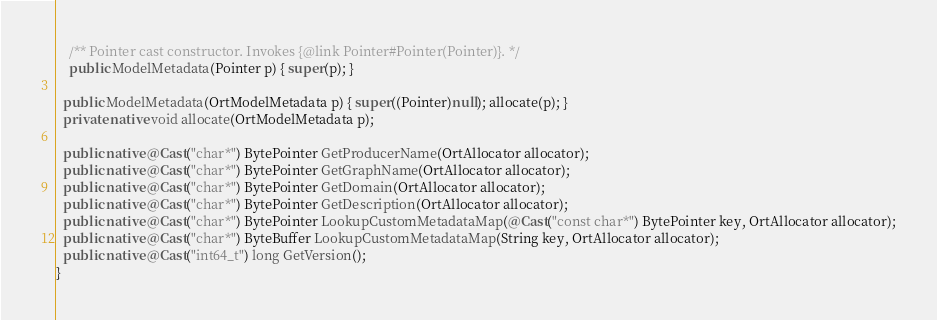<code> <loc_0><loc_0><loc_500><loc_500><_Java_>    /** Pointer cast constructor. Invokes {@link Pointer#Pointer(Pointer)}. */
    public ModelMetadata(Pointer p) { super(p); }

  public ModelMetadata(OrtModelMetadata p) { super((Pointer)null); allocate(p); }
  private native void allocate(OrtModelMetadata p);

  public native @Cast("char*") BytePointer GetProducerName(OrtAllocator allocator);
  public native @Cast("char*") BytePointer GetGraphName(OrtAllocator allocator);
  public native @Cast("char*") BytePointer GetDomain(OrtAllocator allocator);
  public native @Cast("char*") BytePointer GetDescription(OrtAllocator allocator);
  public native @Cast("char*") BytePointer LookupCustomMetadataMap(@Cast("const char*") BytePointer key, OrtAllocator allocator);
  public native @Cast("char*") ByteBuffer LookupCustomMetadataMap(String key, OrtAllocator allocator);
  public native @Cast("int64_t") long GetVersion();
}
</code> 